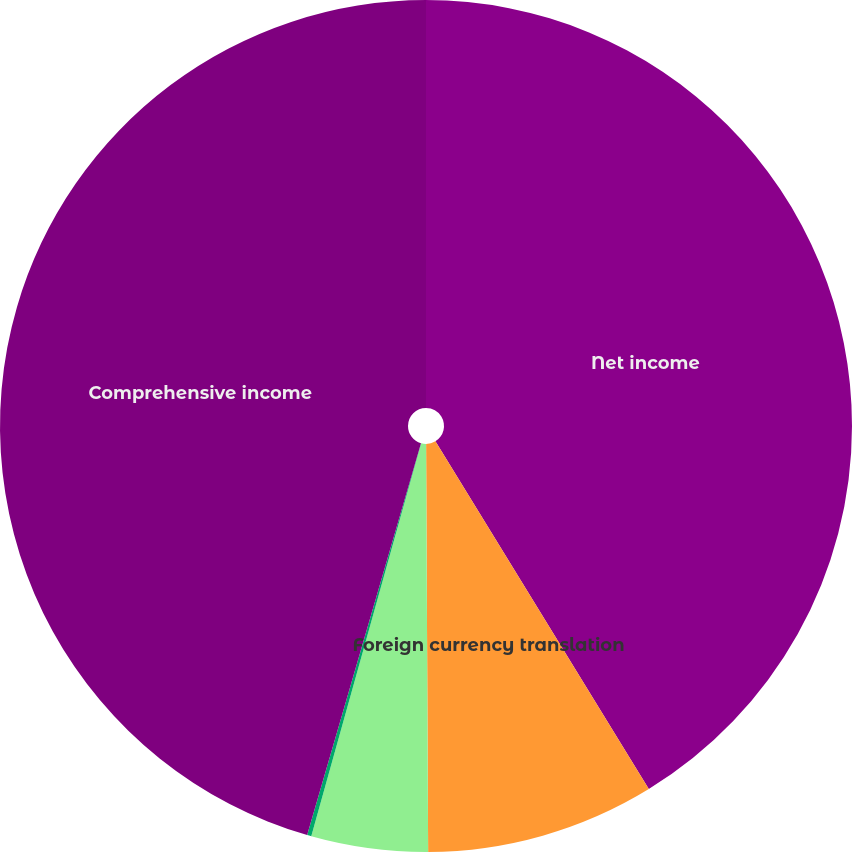Convert chart to OTSL. <chart><loc_0><loc_0><loc_500><loc_500><pie_chart><fcel>Net income<fcel>Foreign currency translation<fcel>Changes in unrealized<fcel>Changes in unrealized holding<fcel>Comprehensive income<nl><fcel>41.24%<fcel>8.68%<fcel>4.42%<fcel>0.16%<fcel>45.5%<nl></chart> 